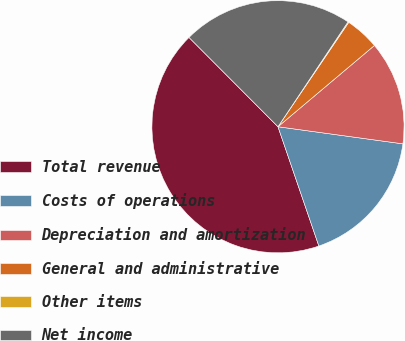<chart> <loc_0><loc_0><loc_500><loc_500><pie_chart><fcel>Total revenue<fcel>Costs of operations<fcel>Depreciation and amortization<fcel>General and administrative<fcel>Other items<fcel>Net income<nl><fcel>42.78%<fcel>17.58%<fcel>13.31%<fcel>4.38%<fcel>0.11%<fcel>21.84%<nl></chart> 